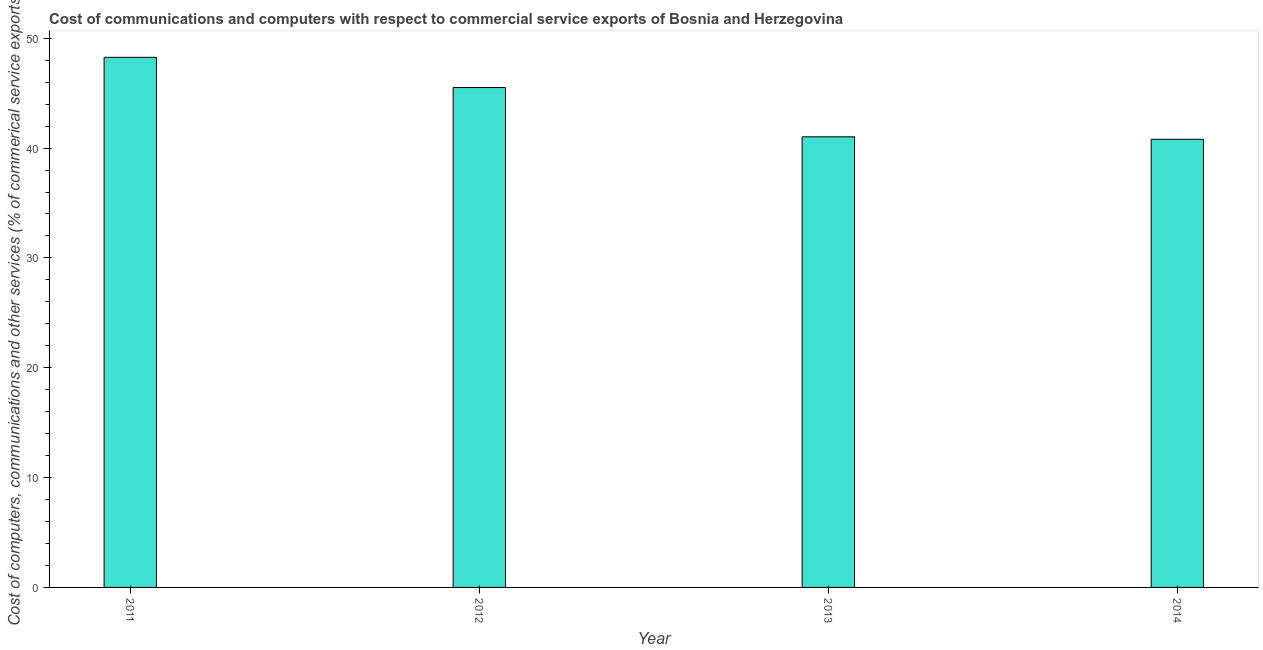Does the graph contain any zero values?
Provide a succinct answer. No. Does the graph contain grids?
Your answer should be very brief. No. What is the title of the graph?
Your answer should be very brief. Cost of communications and computers with respect to commercial service exports of Bosnia and Herzegovina. What is the label or title of the X-axis?
Your response must be concise. Year. What is the label or title of the Y-axis?
Your response must be concise. Cost of computers, communications and other services (% of commerical service exports). What is the cost of communications in 2014?
Offer a terse response. 40.8. Across all years, what is the maximum  computer and other services?
Give a very brief answer. 48.26. Across all years, what is the minimum  computer and other services?
Offer a terse response. 40.8. In which year was the  computer and other services minimum?
Offer a terse response. 2014. What is the sum of the cost of communications?
Offer a terse response. 175.6. What is the difference between the cost of communications in 2013 and 2014?
Keep it short and to the point. 0.22. What is the average  computer and other services per year?
Your answer should be compact. 43.9. What is the median  computer and other services?
Make the answer very short. 43.27. Is the cost of communications in 2011 less than that in 2014?
Your response must be concise. No. Is the difference between the  computer and other services in 2012 and 2013 greater than the difference between any two years?
Keep it short and to the point. No. What is the difference between the highest and the second highest  computer and other services?
Offer a terse response. 2.75. What is the difference between the highest and the lowest cost of communications?
Your answer should be compact. 7.46. How many bars are there?
Ensure brevity in your answer.  4. Are all the bars in the graph horizontal?
Make the answer very short. No. Are the values on the major ticks of Y-axis written in scientific E-notation?
Provide a short and direct response. No. What is the Cost of computers, communications and other services (% of commerical service exports) of 2011?
Offer a terse response. 48.26. What is the Cost of computers, communications and other services (% of commerical service exports) in 2012?
Provide a succinct answer. 45.51. What is the Cost of computers, communications and other services (% of commerical service exports) of 2013?
Make the answer very short. 41.02. What is the Cost of computers, communications and other services (% of commerical service exports) of 2014?
Your answer should be compact. 40.8. What is the difference between the Cost of computers, communications and other services (% of commerical service exports) in 2011 and 2012?
Your response must be concise. 2.75. What is the difference between the Cost of computers, communications and other services (% of commerical service exports) in 2011 and 2013?
Your answer should be compact. 7.24. What is the difference between the Cost of computers, communications and other services (% of commerical service exports) in 2011 and 2014?
Provide a succinct answer. 7.46. What is the difference between the Cost of computers, communications and other services (% of commerical service exports) in 2012 and 2013?
Provide a short and direct response. 4.49. What is the difference between the Cost of computers, communications and other services (% of commerical service exports) in 2012 and 2014?
Your answer should be compact. 4.71. What is the difference between the Cost of computers, communications and other services (% of commerical service exports) in 2013 and 2014?
Make the answer very short. 0.22. What is the ratio of the Cost of computers, communications and other services (% of commerical service exports) in 2011 to that in 2012?
Keep it short and to the point. 1.06. What is the ratio of the Cost of computers, communications and other services (% of commerical service exports) in 2011 to that in 2013?
Offer a very short reply. 1.18. What is the ratio of the Cost of computers, communications and other services (% of commerical service exports) in 2011 to that in 2014?
Offer a terse response. 1.18. What is the ratio of the Cost of computers, communications and other services (% of commerical service exports) in 2012 to that in 2013?
Your answer should be compact. 1.11. What is the ratio of the Cost of computers, communications and other services (% of commerical service exports) in 2012 to that in 2014?
Your answer should be compact. 1.11. 